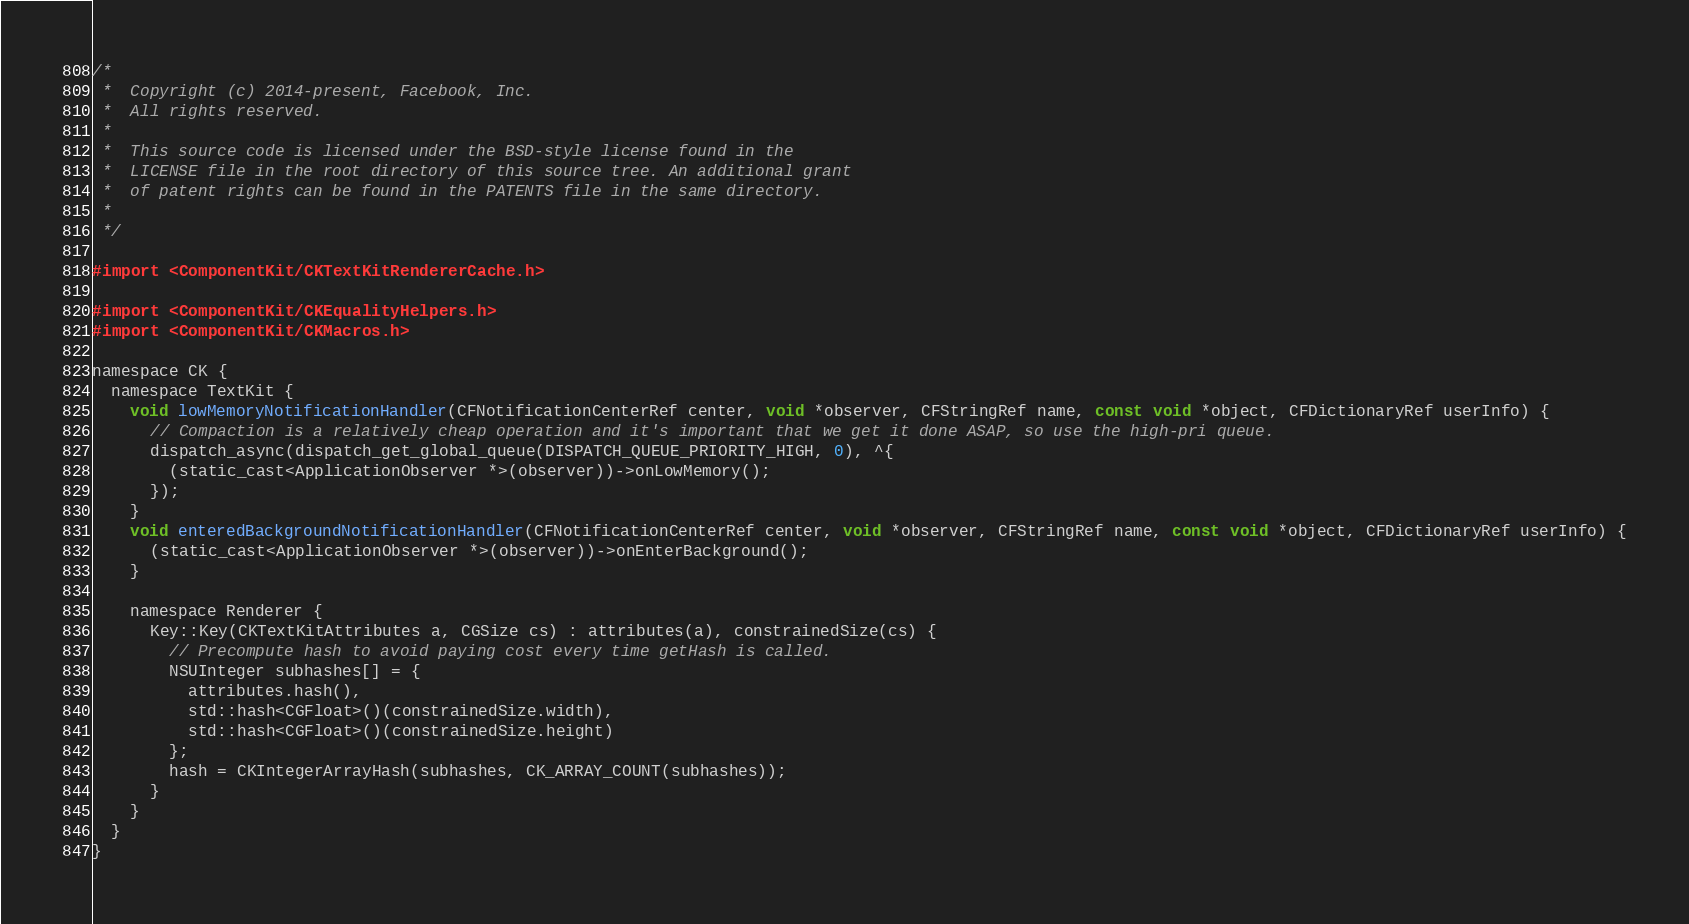<code> <loc_0><loc_0><loc_500><loc_500><_ObjectiveC_>/*
 *  Copyright (c) 2014-present, Facebook, Inc.
 *  All rights reserved.
 *
 *  This source code is licensed under the BSD-style license found in the
 *  LICENSE file in the root directory of this source tree. An additional grant
 *  of patent rights can be found in the PATENTS file in the same directory.
 *
 */

#import <ComponentKit/CKTextKitRendererCache.h>

#import <ComponentKit/CKEqualityHelpers.h>
#import <ComponentKit/CKMacros.h>

namespace CK {
  namespace TextKit {
    void lowMemoryNotificationHandler(CFNotificationCenterRef center, void *observer, CFStringRef name, const void *object, CFDictionaryRef userInfo) {
      // Compaction is a relatively cheap operation and it's important that we get it done ASAP, so use the high-pri queue.
      dispatch_async(dispatch_get_global_queue(DISPATCH_QUEUE_PRIORITY_HIGH, 0), ^{
        (static_cast<ApplicationObserver *>(observer))->onLowMemory();
      });
    }
    void enteredBackgroundNotificationHandler(CFNotificationCenterRef center, void *observer, CFStringRef name, const void *object, CFDictionaryRef userInfo) {
      (static_cast<ApplicationObserver *>(observer))->onEnterBackground();
    }

    namespace Renderer {
      Key::Key(CKTextKitAttributes a, CGSize cs) : attributes(a), constrainedSize(cs) {
        // Precompute hash to avoid paying cost every time getHash is called.
        NSUInteger subhashes[] = {
          attributes.hash(),
          std::hash<CGFloat>()(constrainedSize.width),
          std::hash<CGFloat>()(constrainedSize.height)
        };
        hash = CKIntegerArrayHash(subhashes, CK_ARRAY_COUNT(subhashes));
      }
    }
  }
}
</code> 